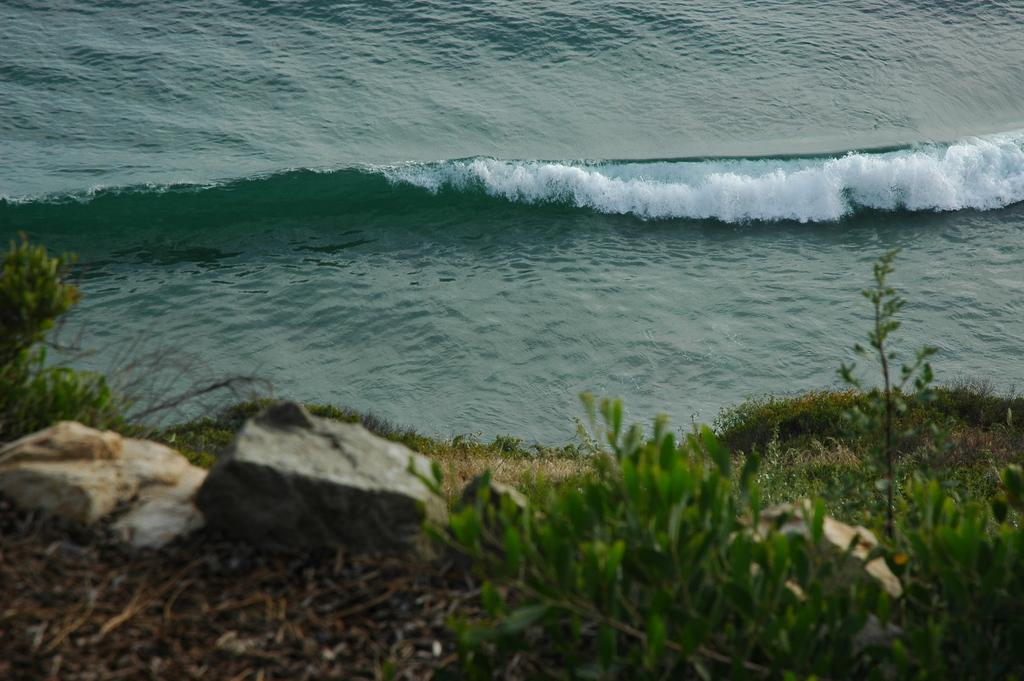What type of terrain is depicted in the image? There are rocks and grass on the ground in the image. Is there any water visible in the image? Yes, there is water visible in the image. What is the color of the water in the image? The water appears to be green in color. How many members are on the team that is playing in the water in the image? There is no team or people playing in the water in the image; it only shows rocks, grass, and green water. 